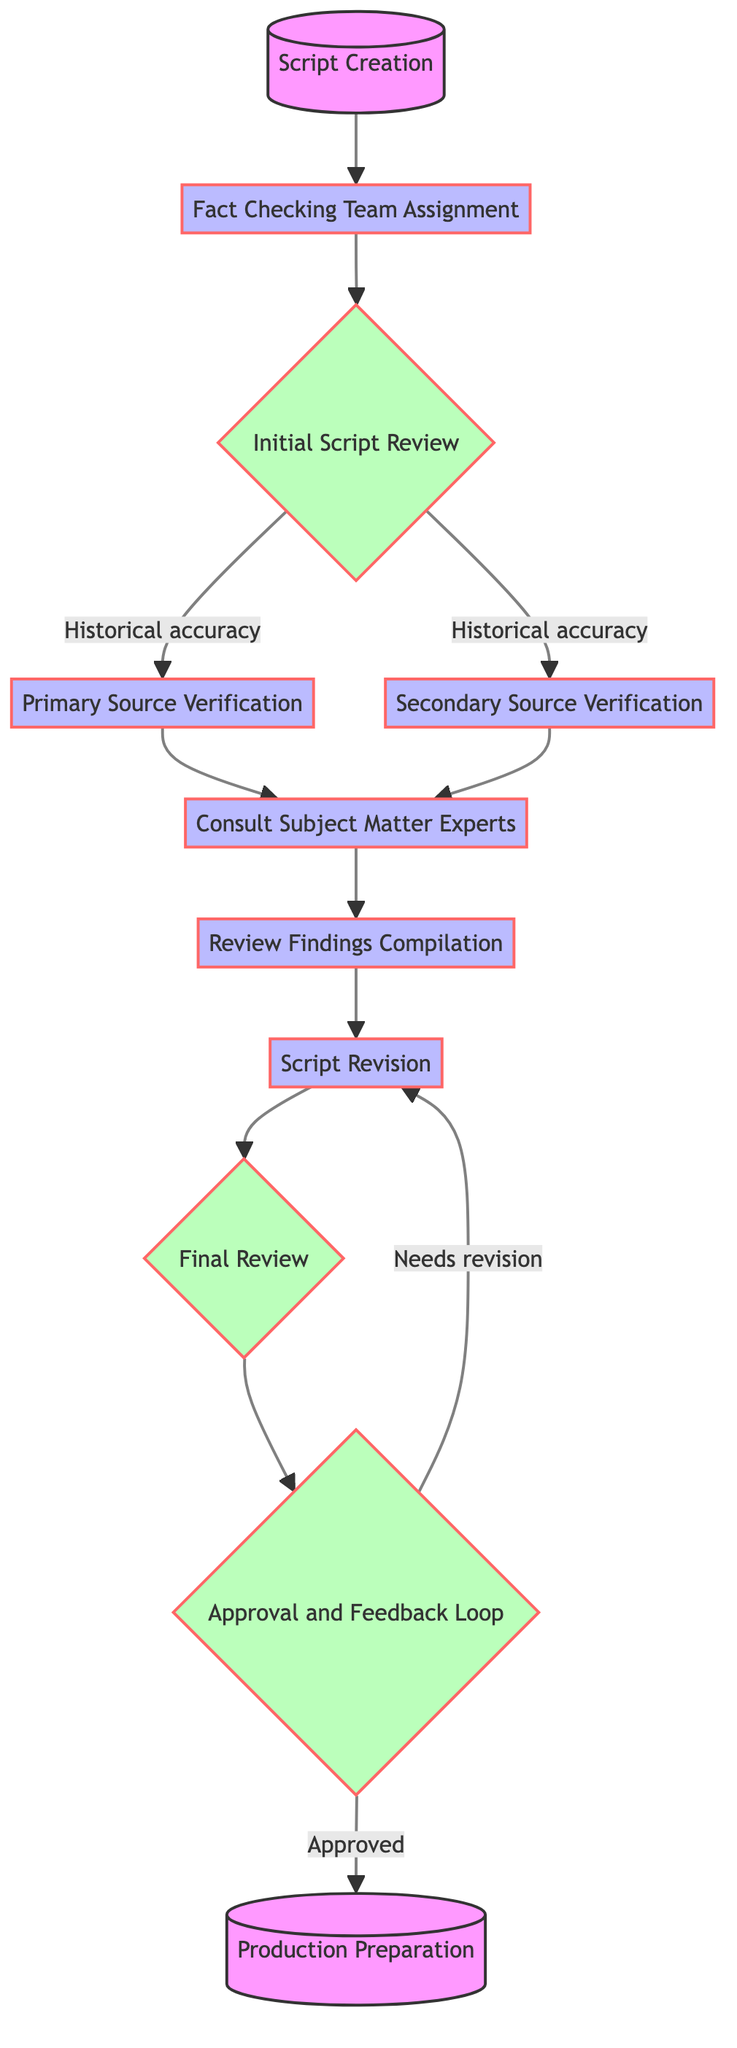What is the first step in the workflow? The first step in the workflow is "Script Creation," denoted as node 1 in the diagram. This node indicates the initial stage where the screenwriter creates the script before any fact-checking process takes place.
Answer: Script Creation How many nodes are in the workflow? The workflow diagram contains a total of eleven nodes, each representing a distinct stage in the process of verifying historical facts in a television script.
Answer: Eleven Which node comes after "Consult Subject Matter Experts"? After "Consult Subject Matter Experts," the next node is "Review Findings Compilation," designated as node 7 in the diagram. The flow indicates that after consulting experts, their input leads directly to compiling the findings.
Answer: Review Findings Compilation What are the two types of verification used during the initial script review? During the "Initial Script Review," two types of verification are utilized: "Primary Source Verification" (node 4) and "Secondary Source Verification" (node 5). The diagram explicitly shows that both flow from the initial review stage.
Answer: Primary and Secondary Source Verification Which step requires the screenwriter to make revisions? The step requiring the screenwriter to make revisions is called "Script Revision," represented as node 8. This step occurs after findings have been compiled and reviewed by experts, necessitating rewrites based on their feedback.
Answer: Script Revision What happens if the final review indicates that changes are needed? If the final review indicates that changes are needed, the workflow loops back to the "Script Revision" step (node 8), meaning additional revisions will occur based on feedback from the final review (node 9).
Answer: Needs revision What is the last step before production preparation? The last step before "Production Preparation" is the "Approval and Feedback Loop," identified as node 10. This stage involves ensuring the script has passed all reviews and received final approval before it moves into production.
Answer: Approval and Feedback Loop How does the fact-checking team communicate feedback? The fact-checking team communicates feedback through a continuous loop back to the screenwriter during the "Approval and Feedback Loop" (node 10), ensuring that any necessary changes are made before final approval.
Answer: Feedback Loop Which nodes involve consultation with experts? The nodes that involve consultation with experts are "Consult Subject Matter Experts" (node 6) and "Review Findings Compilation" (node 7). Expert consultation occurs prior to compiling findings based on their insights.
Answer: Consult Subject Matter Experts and Review Findings Compilation 